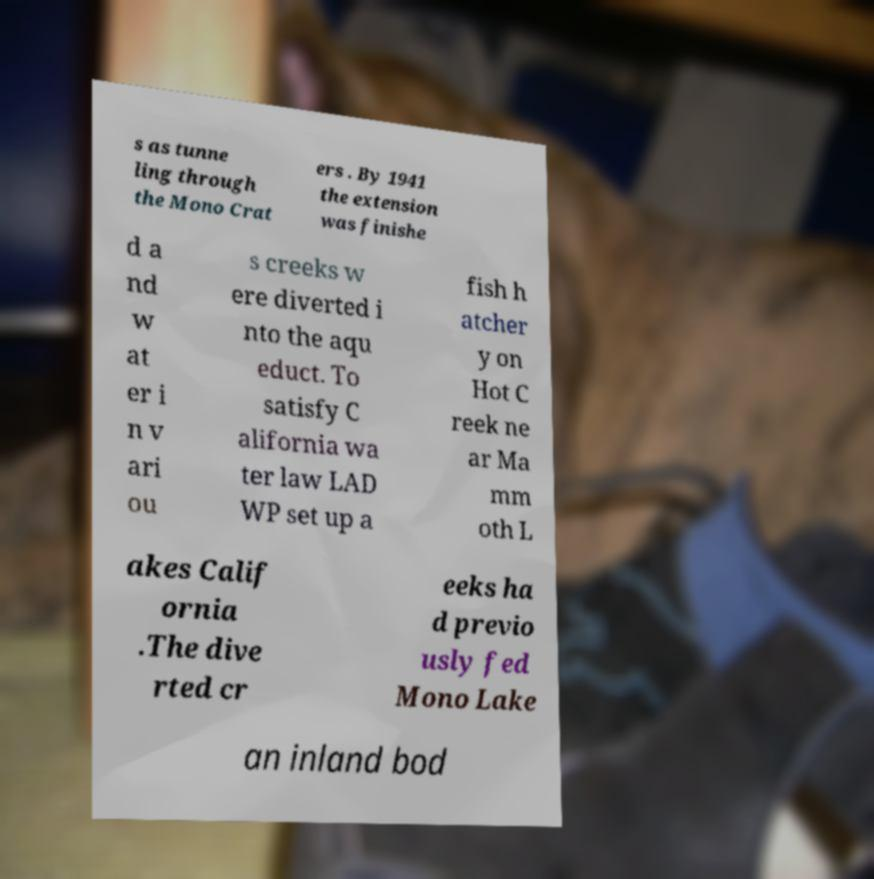Could you assist in decoding the text presented in this image and type it out clearly? s as tunne ling through the Mono Crat ers . By 1941 the extension was finishe d a nd w at er i n v ari ou s creeks w ere diverted i nto the aqu educt. To satisfy C alifornia wa ter law LAD WP set up a fish h atcher y on Hot C reek ne ar Ma mm oth L akes Calif ornia .The dive rted cr eeks ha d previo usly fed Mono Lake an inland bod 